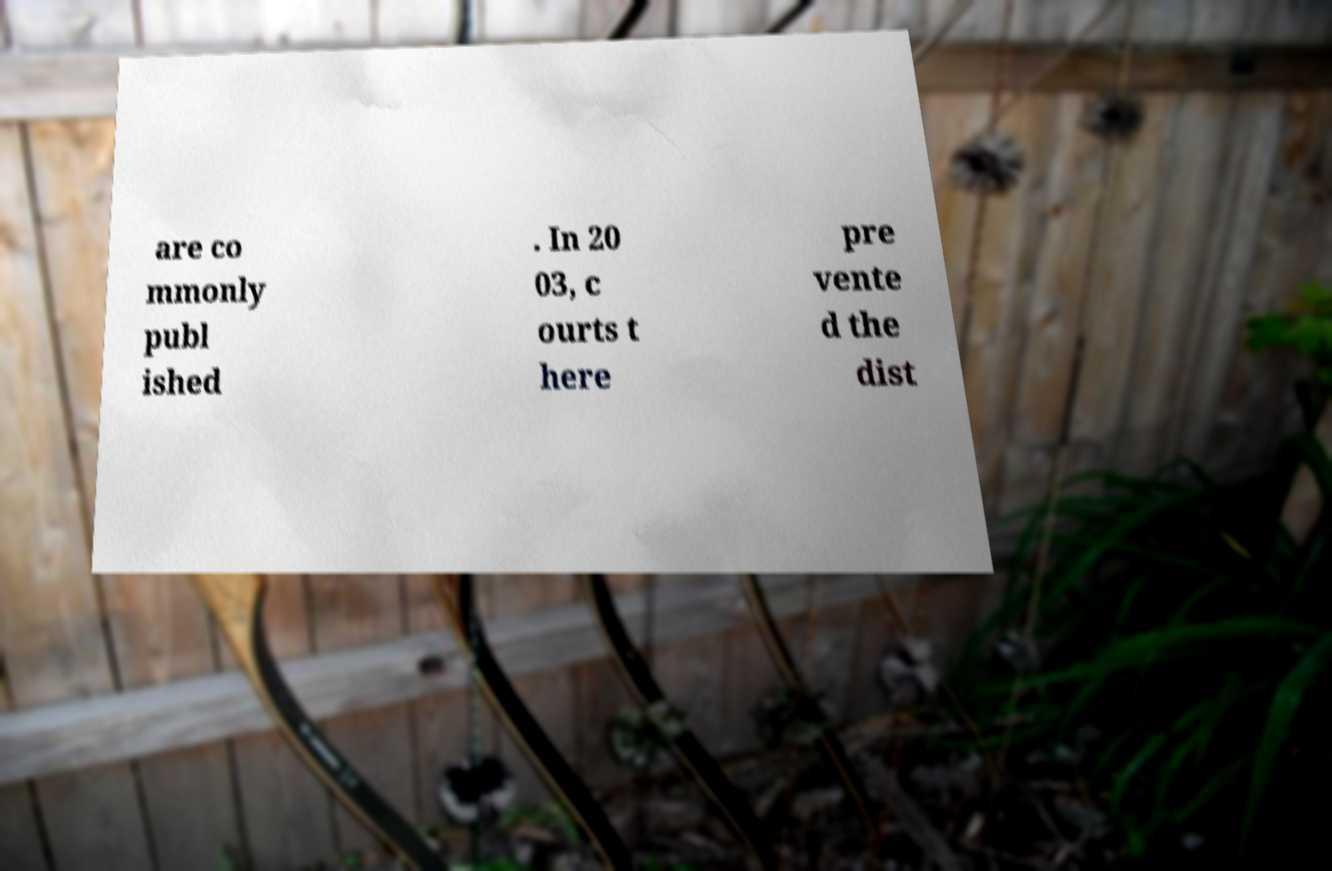For documentation purposes, I need the text within this image transcribed. Could you provide that? are co mmonly publ ished . In 20 03, c ourts t here pre vente d the dist 